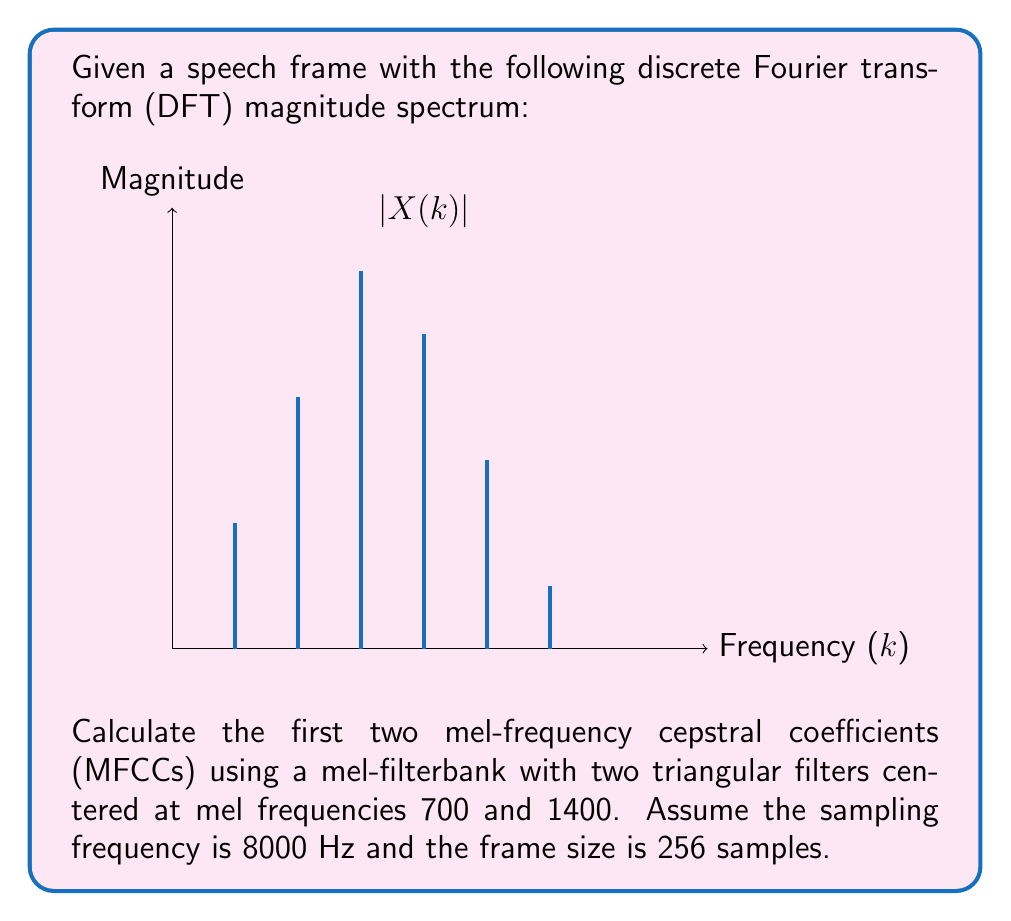Could you help me with this problem? To calculate the MFCCs, we'll follow these steps:

1) Convert the center frequencies to mel scale:
   $m = 2595 \log_{10}(1 + \frac{f}{700})$
   $m_1 = 2595 \log_{10}(1 + \frac{700}{700}) \approx 767$ mel
   $m_2 = 2595 \log_{10}(1 + \frac{1400}{700}) \approx 1362$ mel

2) Create two triangular mel filters based on these center frequencies.

3) Apply the mel filters to the magnitude spectrum:
   $H_1 = [0, 0.5, 1, 0.5, 0, 0, 0, 0]$
   $H_2 = [0, 0, 0, 0.5, 1, 0.5, 0, 0]$
   
   $S_1 = \sum_{k=0}^7 |X(k)| \cdot H_1(k) = 0.5 \cdot 2 + 1 \cdot 4 + 0.5 \cdot 6 = 7$
   $S_2 = \sum_{k=0}^7 |X(k)| \cdot H_2(k) = 0.5 \cdot 6 + 1 \cdot 5 + 0.5 \cdot 3 = 8.5$

4) Take the logarithm of the filterbank energies:
   $\log(S_1) = \log(7) \approx 1.95$
   $\log(S_2) = \log(8.5) \approx 2.14$

5) Apply the discrete cosine transform (DCT) to get the MFCCs:
   $c_n = \sqrt{\frac{2}{N}} \sum_{m=1}^{N} \log(S_m) \cos(\frac{\pi n (m-0.5)}{N})$, where $N=2$ (number of filters)

   For $n=0$:
   $c_0 = \sqrt{\frac{2}{2}} [\log(S_1) \cos(0) + \log(S_2) \cos(0)] = 1.95 + 2.14 = 4.09$

   For $n=1$:
   $c_1 = \sqrt{\frac{2}{2}} [\log(S_1) \cos(\frac{\pi}{4}) + \log(S_2) \cos(\frac{3\pi}{4})] \approx -0.13$
Answer: $c_0 \approx 4.09$, $c_1 \approx -0.13$ 